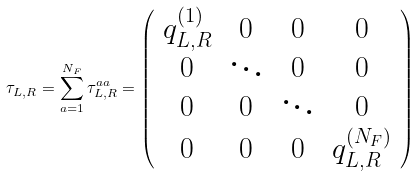<formula> <loc_0><loc_0><loc_500><loc_500>\tau _ { L , R } = \sum _ { a = 1 } ^ { N _ { F } } \tau _ { L , R } ^ { a a } = \left ( \begin{array} { c c c c } q _ { L , R } ^ { ( 1 ) } & 0 & 0 & 0 \\ 0 & \ddots & 0 & 0 \\ 0 & 0 & \ddots & 0 \\ 0 & 0 & 0 & q _ { L , R } ^ { ( N _ { F } ) } \end{array} \right )</formula> 